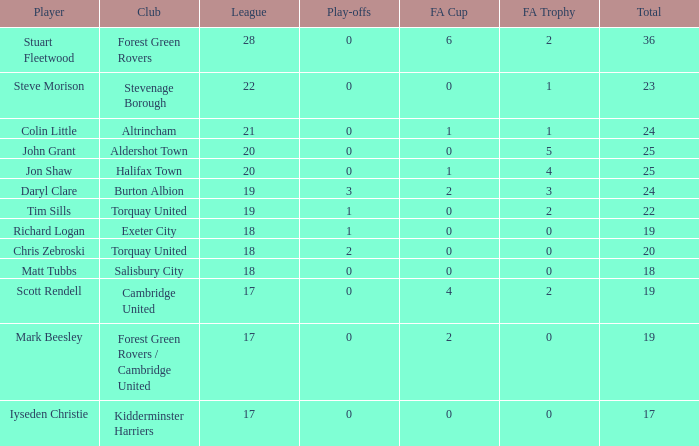For john grant, what was the mean count of play-offs when the league number was above 18 and the overall number was more than 25? None. 